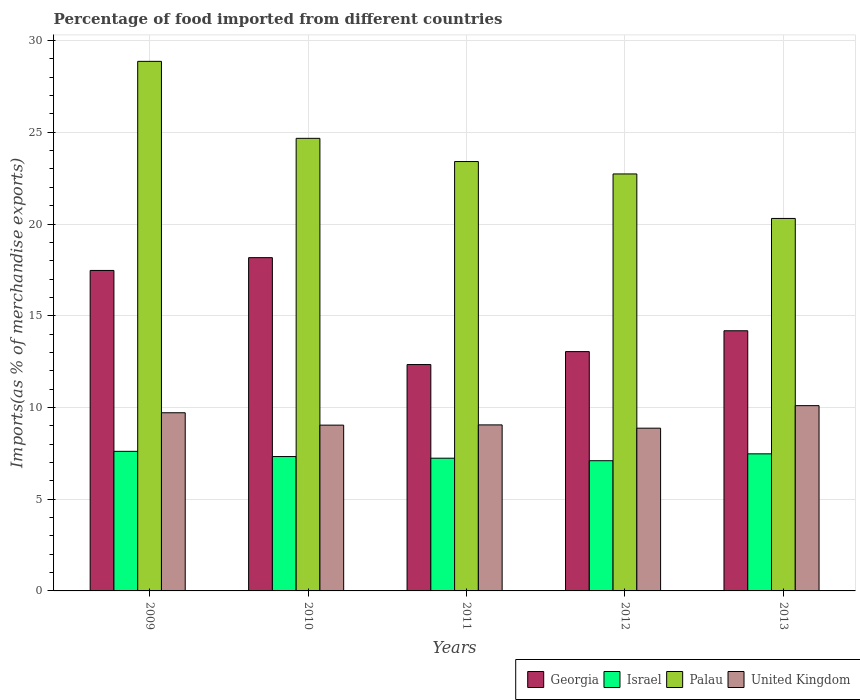How many groups of bars are there?
Make the answer very short. 5. Are the number of bars per tick equal to the number of legend labels?
Provide a succinct answer. Yes. Are the number of bars on each tick of the X-axis equal?
Your response must be concise. Yes. How many bars are there on the 4th tick from the left?
Offer a very short reply. 4. How many bars are there on the 4th tick from the right?
Offer a terse response. 4. In how many cases, is the number of bars for a given year not equal to the number of legend labels?
Your answer should be compact. 0. What is the percentage of imports to different countries in Israel in 2009?
Provide a short and direct response. 7.61. Across all years, what is the maximum percentage of imports to different countries in Israel?
Make the answer very short. 7.61. Across all years, what is the minimum percentage of imports to different countries in Israel?
Your answer should be compact. 7.1. What is the total percentage of imports to different countries in Georgia in the graph?
Your response must be concise. 75.2. What is the difference between the percentage of imports to different countries in Palau in 2010 and that in 2011?
Your answer should be compact. 1.27. What is the difference between the percentage of imports to different countries in Israel in 2009 and the percentage of imports to different countries in United Kingdom in 2013?
Offer a terse response. -2.49. What is the average percentage of imports to different countries in Israel per year?
Make the answer very short. 7.35. In the year 2009, what is the difference between the percentage of imports to different countries in Palau and percentage of imports to different countries in Georgia?
Give a very brief answer. 11.4. In how many years, is the percentage of imports to different countries in Israel greater than 21 %?
Ensure brevity in your answer.  0. What is the ratio of the percentage of imports to different countries in Georgia in 2010 to that in 2012?
Offer a very short reply. 1.39. Is the difference between the percentage of imports to different countries in Palau in 2010 and 2012 greater than the difference between the percentage of imports to different countries in Georgia in 2010 and 2012?
Your response must be concise. No. What is the difference between the highest and the second highest percentage of imports to different countries in Palau?
Provide a short and direct response. 4.2. What is the difference between the highest and the lowest percentage of imports to different countries in Israel?
Your response must be concise. 0.51. In how many years, is the percentage of imports to different countries in Israel greater than the average percentage of imports to different countries in Israel taken over all years?
Your answer should be very brief. 2. What does the 4th bar from the left in 2012 represents?
Offer a terse response. United Kingdom. What does the 4th bar from the right in 2011 represents?
Your answer should be very brief. Georgia. Is it the case that in every year, the sum of the percentage of imports to different countries in Palau and percentage of imports to different countries in United Kingdom is greater than the percentage of imports to different countries in Israel?
Offer a very short reply. Yes. Are all the bars in the graph horizontal?
Give a very brief answer. No. How many years are there in the graph?
Offer a terse response. 5. Are the values on the major ticks of Y-axis written in scientific E-notation?
Give a very brief answer. No. Does the graph contain grids?
Make the answer very short. Yes. What is the title of the graph?
Your answer should be very brief. Percentage of food imported from different countries. Does "Fiji" appear as one of the legend labels in the graph?
Make the answer very short. No. What is the label or title of the X-axis?
Offer a very short reply. Years. What is the label or title of the Y-axis?
Offer a terse response. Imports(as % of merchandise exports). What is the Imports(as % of merchandise exports) of Georgia in 2009?
Your answer should be very brief. 17.47. What is the Imports(as % of merchandise exports) of Israel in 2009?
Offer a terse response. 7.61. What is the Imports(as % of merchandise exports) in Palau in 2009?
Make the answer very short. 28.87. What is the Imports(as % of merchandise exports) in United Kingdom in 2009?
Give a very brief answer. 9.71. What is the Imports(as % of merchandise exports) in Georgia in 2010?
Ensure brevity in your answer.  18.17. What is the Imports(as % of merchandise exports) in Israel in 2010?
Keep it short and to the point. 7.32. What is the Imports(as % of merchandise exports) of Palau in 2010?
Give a very brief answer. 24.67. What is the Imports(as % of merchandise exports) of United Kingdom in 2010?
Ensure brevity in your answer.  9.04. What is the Imports(as % of merchandise exports) in Georgia in 2011?
Your answer should be very brief. 12.34. What is the Imports(as % of merchandise exports) of Israel in 2011?
Ensure brevity in your answer.  7.24. What is the Imports(as % of merchandise exports) of Palau in 2011?
Make the answer very short. 23.4. What is the Imports(as % of merchandise exports) in United Kingdom in 2011?
Your response must be concise. 9.05. What is the Imports(as % of merchandise exports) in Georgia in 2012?
Provide a succinct answer. 13.04. What is the Imports(as % of merchandise exports) of Israel in 2012?
Your answer should be very brief. 7.1. What is the Imports(as % of merchandise exports) of Palau in 2012?
Provide a succinct answer. 22.73. What is the Imports(as % of merchandise exports) in United Kingdom in 2012?
Provide a succinct answer. 8.87. What is the Imports(as % of merchandise exports) of Georgia in 2013?
Your response must be concise. 14.18. What is the Imports(as % of merchandise exports) in Israel in 2013?
Provide a succinct answer. 7.47. What is the Imports(as % of merchandise exports) of Palau in 2013?
Give a very brief answer. 20.3. What is the Imports(as % of merchandise exports) in United Kingdom in 2013?
Provide a short and direct response. 10.1. Across all years, what is the maximum Imports(as % of merchandise exports) in Georgia?
Your answer should be very brief. 18.17. Across all years, what is the maximum Imports(as % of merchandise exports) of Israel?
Your response must be concise. 7.61. Across all years, what is the maximum Imports(as % of merchandise exports) in Palau?
Provide a succinct answer. 28.87. Across all years, what is the maximum Imports(as % of merchandise exports) of United Kingdom?
Give a very brief answer. 10.1. Across all years, what is the minimum Imports(as % of merchandise exports) of Georgia?
Keep it short and to the point. 12.34. Across all years, what is the minimum Imports(as % of merchandise exports) in Israel?
Provide a short and direct response. 7.1. Across all years, what is the minimum Imports(as % of merchandise exports) of Palau?
Your answer should be very brief. 20.3. Across all years, what is the minimum Imports(as % of merchandise exports) in United Kingdom?
Your answer should be very brief. 8.87. What is the total Imports(as % of merchandise exports) in Georgia in the graph?
Ensure brevity in your answer.  75.2. What is the total Imports(as % of merchandise exports) in Israel in the graph?
Provide a succinct answer. 36.74. What is the total Imports(as % of merchandise exports) in Palau in the graph?
Offer a very short reply. 119.97. What is the total Imports(as % of merchandise exports) in United Kingdom in the graph?
Keep it short and to the point. 46.77. What is the difference between the Imports(as % of merchandise exports) of Georgia in 2009 and that in 2010?
Your response must be concise. -0.7. What is the difference between the Imports(as % of merchandise exports) of Israel in 2009 and that in 2010?
Give a very brief answer. 0.28. What is the difference between the Imports(as % of merchandise exports) in Palau in 2009 and that in 2010?
Provide a succinct answer. 4.2. What is the difference between the Imports(as % of merchandise exports) of United Kingdom in 2009 and that in 2010?
Ensure brevity in your answer.  0.67. What is the difference between the Imports(as % of merchandise exports) of Georgia in 2009 and that in 2011?
Your answer should be compact. 5.13. What is the difference between the Imports(as % of merchandise exports) in Israel in 2009 and that in 2011?
Make the answer very short. 0.37. What is the difference between the Imports(as % of merchandise exports) of Palau in 2009 and that in 2011?
Provide a succinct answer. 5.46. What is the difference between the Imports(as % of merchandise exports) in United Kingdom in 2009 and that in 2011?
Your response must be concise. 0.66. What is the difference between the Imports(as % of merchandise exports) of Georgia in 2009 and that in 2012?
Your answer should be very brief. 4.42. What is the difference between the Imports(as % of merchandise exports) in Israel in 2009 and that in 2012?
Your answer should be compact. 0.51. What is the difference between the Imports(as % of merchandise exports) of Palau in 2009 and that in 2012?
Ensure brevity in your answer.  6.14. What is the difference between the Imports(as % of merchandise exports) in United Kingdom in 2009 and that in 2012?
Offer a terse response. 0.84. What is the difference between the Imports(as % of merchandise exports) of Georgia in 2009 and that in 2013?
Offer a terse response. 3.29. What is the difference between the Imports(as % of merchandise exports) of Israel in 2009 and that in 2013?
Provide a succinct answer. 0.14. What is the difference between the Imports(as % of merchandise exports) in Palau in 2009 and that in 2013?
Keep it short and to the point. 8.56. What is the difference between the Imports(as % of merchandise exports) in United Kingdom in 2009 and that in 2013?
Offer a terse response. -0.39. What is the difference between the Imports(as % of merchandise exports) in Georgia in 2010 and that in 2011?
Provide a short and direct response. 5.83. What is the difference between the Imports(as % of merchandise exports) of Israel in 2010 and that in 2011?
Offer a terse response. 0.09. What is the difference between the Imports(as % of merchandise exports) of Palau in 2010 and that in 2011?
Give a very brief answer. 1.27. What is the difference between the Imports(as % of merchandise exports) of United Kingdom in 2010 and that in 2011?
Give a very brief answer. -0.01. What is the difference between the Imports(as % of merchandise exports) of Georgia in 2010 and that in 2012?
Make the answer very short. 5.12. What is the difference between the Imports(as % of merchandise exports) of Israel in 2010 and that in 2012?
Your answer should be compact. 0.23. What is the difference between the Imports(as % of merchandise exports) in Palau in 2010 and that in 2012?
Make the answer very short. 1.94. What is the difference between the Imports(as % of merchandise exports) in United Kingdom in 2010 and that in 2012?
Provide a succinct answer. 0.17. What is the difference between the Imports(as % of merchandise exports) of Georgia in 2010 and that in 2013?
Offer a very short reply. 3.99. What is the difference between the Imports(as % of merchandise exports) in Israel in 2010 and that in 2013?
Keep it short and to the point. -0.15. What is the difference between the Imports(as % of merchandise exports) of Palau in 2010 and that in 2013?
Offer a very short reply. 4.37. What is the difference between the Imports(as % of merchandise exports) of United Kingdom in 2010 and that in 2013?
Your answer should be very brief. -1.06. What is the difference between the Imports(as % of merchandise exports) in Georgia in 2011 and that in 2012?
Your answer should be very brief. -0.71. What is the difference between the Imports(as % of merchandise exports) of Israel in 2011 and that in 2012?
Provide a short and direct response. 0.14. What is the difference between the Imports(as % of merchandise exports) of Palau in 2011 and that in 2012?
Your answer should be compact. 0.68. What is the difference between the Imports(as % of merchandise exports) of United Kingdom in 2011 and that in 2012?
Provide a short and direct response. 0.18. What is the difference between the Imports(as % of merchandise exports) of Georgia in 2011 and that in 2013?
Your answer should be very brief. -1.84. What is the difference between the Imports(as % of merchandise exports) in Israel in 2011 and that in 2013?
Your response must be concise. -0.24. What is the difference between the Imports(as % of merchandise exports) of Palau in 2011 and that in 2013?
Offer a very short reply. 3.1. What is the difference between the Imports(as % of merchandise exports) in United Kingdom in 2011 and that in 2013?
Your answer should be compact. -1.05. What is the difference between the Imports(as % of merchandise exports) in Georgia in 2012 and that in 2013?
Offer a very short reply. -1.14. What is the difference between the Imports(as % of merchandise exports) in Israel in 2012 and that in 2013?
Provide a short and direct response. -0.38. What is the difference between the Imports(as % of merchandise exports) in Palau in 2012 and that in 2013?
Your answer should be compact. 2.43. What is the difference between the Imports(as % of merchandise exports) of United Kingdom in 2012 and that in 2013?
Give a very brief answer. -1.23. What is the difference between the Imports(as % of merchandise exports) in Georgia in 2009 and the Imports(as % of merchandise exports) in Israel in 2010?
Your answer should be very brief. 10.14. What is the difference between the Imports(as % of merchandise exports) of Georgia in 2009 and the Imports(as % of merchandise exports) of Palau in 2010?
Ensure brevity in your answer.  -7.2. What is the difference between the Imports(as % of merchandise exports) of Georgia in 2009 and the Imports(as % of merchandise exports) of United Kingdom in 2010?
Provide a succinct answer. 8.43. What is the difference between the Imports(as % of merchandise exports) of Israel in 2009 and the Imports(as % of merchandise exports) of Palau in 2010?
Your response must be concise. -17.06. What is the difference between the Imports(as % of merchandise exports) in Israel in 2009 and the Imports(as % of merchandise exports) in United Kingdom in 2010?
Give a very brief answer. -1.43. What is the difference between the Imports(as % of merchandise exports) of Palau in 2009 and the Imports(as % of merchandise exports) of United Kingdom in 2010?
Make the answer very short. 19.83. What is the difference between the Imports(as % of merchandise exports) of Georgia in 2009 and the Imports(as % of merchandise exports) of Israel in 2011?
Provide a short and direct response. 10.23. What is the difference between the Imports(as % of merchandise exports) in Georgia in 2009 and the Imports(as % of merchandise exports) in Palau in 2011?
Keep it short and to the point. -5.94. What is the difference between the Imports(as % of merchandise exports) in Georgia in 2009 and the Imports(as % of merchandise exports) in United Kingdom in 2011?
Your answer should be compact. 8.42. What is the difference between the Imports(as % of merchandise exports) of Israel in 2009 and the Imports(as % of merchandise exports) of Palau in 2011?
Ensure brevity in your answer.  -15.8. What is the difference between the Imports(as % of merchandise exports) in Israel in 2009 and the Imports(as % of merchandise exports) in United Kingdom in 2011?
Ensure brevity in your answer.  -1.44. What is the difference between the Imports(as % of merchandise exports) in Palau in 2009 and the Imports(as % of merchandise exports) in United Kingdom in 2011?
Ensure brevity in your answer.  19.82. What is the difference between the Imports(as % of merchandise exports) of Georgia in 2009 and the Imports(as % of merchandise exports) of Israel in 2012?
Offer a terse response. 10.37. What is the difference between the Imports(as % of merchandise exports) in Georgia in 2009 and the Imports(as % of merchandise exports) in Palau in 2012?
Ensure brevity in your answer.  -5.26. What is the difference between the Imports(as % of merchandise exports) in Georgia in 2009 and the Imports(as % of merchandise exports) in United Kingdom in 2012?
Offer a very short reply. 8.6. What is the difference between the Imports(as % of merchandise exports) in Israel in 2009 and the Imports(as % of merchandise exports) in Palau in 2012?
Offer a very short reply. -15.12. What is the difference between the Imports(as % of merchandise exports) in Israel in 2009 and the Imports(as % of merchandise exports) in United Kingdom in 2012?
Provide a succinct answer. -1.26. What is the difference between the Imports(as % of merchandise exports) of Palau in 2009 and the Imports(as % of merchandise exports) of United Kingdom in 2012?
Provide a succinct answer. 20. What is the difference between the Imports(as % of merchandise exports) of Georgia in 2009 and the Imports(as % of merchandise exports) of Israel in 2013?
Provide a short and direct response. 10. What is the difference between the Imports(as % of merchandise exports) of Georgia in 2009 and the Imports(as % of merchandise exports) of Palau in 2013?
Provide a short and direct response. -2.83. What is the difference between the Imports(as % of merchandise exports) of Georgia in 2009 and the Imports(as % of merchandise exports) of United Kingdom in 2013?
Make the answer very short. 7.37. What is the difference between the Imports(as % of merchandise exports) in Israel in 2009 and the Imports(as % of merchandise exports) in Palau in 2013?
Keep it short and to the point. -12.69. What is the difference between the Imports(as % of merchandise exports) in Israel in 2009 and the Imports(as % of merchandise exports) in United Kingdom in 2013?
Your answer should be very brief. -2.49. What is the difference between the Imports(as % of merchandise exports) in Palau in 2009 and the Imports(as % of merchandise exports) in United Kingdom in 2013?
Provide a short and direct response. 18.77. What is the difference between the Imports(as % of merchandise exports) in Georgia in 2010 and the Imports(as % of merchandise exports) in Israel in 2011?
Offer a terse response. 10.93. What is the difference between the Imports(as % of merchandise exports) in Georgia in 2010 and the Imports(as % of merchandise exports) in Palau in 2011?
Give a very brief answer. -5.24. What is the difference between the Imports(as % of merchandise exports) of Georgia in 2010 and the Imports(as % of merchandise exports) of United Kingdom in 2011?
Offer a very short reply. 9.12. What is the difference between the Imports(as % of merchandise exports) of Israel in 2010 and the Imports(as % of merchandise exports) of Palau in 2011?
Your answer should be compact. -16.08. What is the difference between the Imports(as % of merchandise exports) in Israel in 2010 and the Imports(as % of merchandise exports) in United Kingdom in 2011?
Provide a succinct answer. -1.73. What is the difference between the Imports(as % of merchandise exports) of Palau in 2010 and the Imports(as % of merchandise exports) of United Kingdom in 2011?
Your answer should be compact. 15.62. What is the difference between the Imports(as % of merchandise exports) in Georgia in 2010 and the Imports(as % of merchandise exports) in Israel in 2012?
Give a very brief answer. 11.07. What is the difference between the Imports(as % of merchandise exports) of Georgia in 2010 and the Imports(as % of merchandise exports) of Palau in 2012?
Your answer should be very brief. -4.56. What is the difference between the Imports(as % of merchandise exports) of Georgia in 2010 and the Imports(as % of merchandise exports) of United Kingdom in 2012?
Provide a succinct answer. 9.3. What is the difference between the Imports(as % of merchandise exports) in Israel in 2010 and the Imports(as % of merchandise exports) in Palau in 2012?
Keep it short and to the point. -15.4. What is the difference between the Imports(as % of merchandise exports) of Israel in 2010 and the Imports(as % of merchandise exports) of United Kingdom in 2012?
Give a very brief answer. -1.55. What is the difference between the Imports(as % of merchandise exports) in Palau in 2010 and the Imports(as % of merchandise exports) in United Kingdom in 2012?
Offer a very short reply. 15.8. What is the difference between the Imports(as % of merchandise exports) of Georgia in 2010 and the Imports(as % of merchandise exports) of Israel in 2013?
Offer a terse response. 10.69. What is the difference between the Imports(as % of merchandise exports) in Georgia in 2010 and the Imports(as % of merchandise exports) in Palau in 2013?
Provide a succinct answer. -2.14. What is the difference between the Imports(as % of merchandise exports) of Georgia in 2010 and the Imports(as % of merchandise exports) of United Kingdom in 2013?
Give a very brief answer. 8.07. What is the difference between the Imports(as % of merchandise exports) in Israel in 2010 and the Imports(as % of merchandise exports) in Palau in 2013?
Offer a terse response. -12.98. What is the difference between the Imports(as % of merchandise exports) in Israel in 2010 and the Imports(as % of merchandise exports) in United Kingdom in 2013?
Your response must be concise. -2.77. What is the difference between the Imports(as % of merchandise exports) of Palau in 2010 and the Imports(as % of merchandise exports) of United Kingdom in 2013?
Your answer should be compact. 14.57. What is the difference between the Imports(as % of merchandise exports) of Georgia in 2011 and the Imports(as % of merchandise exports) of Israel in 2012?
Give a very brief answer. 5.24. What is the difference between the Imports(as % of merchandise exports) of Georgia in 2011 and the Imports(as % of merchandise exports) of Palau in 2012?
Offer a terse response. -10.39. What is the difference between the Imports(as % of merchandise exports) of Georgia in 2011 and the Imports(as % of merchandise exports) of United Kingdom in 2012?
Provide a short and direct response. 3.47. What is the difference between the Imports(as % of merchandise exports) in Israel in 2011 and the Imports(as % of merchandise exports) in Palau in 2012?
Your response must be concise. -15.49. What is the difference between the Imports(as % of merchandise exports) in Israel in 2011 and the Imports(as % of merchandise exports) in United Kingdom in 2012?
Offer a terse response. -1.64. What is the difference between the Imports(as % of merchandise exports) of Palau in 2011 and the Imports(as % of merchandise exports) of United Kingdom in 2012?
Ensure brevity in your answer.  14.53. What is the difference between the Imports(as % of merchandise exports) in Georgia in 2011 and the Imports(as % of merchandise exports) in Israel in 2013?
Make the answer very short. 4.87. What is the difference between the Imports(as % of merchandise exports) of Georgia in 2011 and the Imports(as % of merchandise exports) of Palau in 2013?
Your answer should be very brief. -7.96. What is the difference between the Imports(as % of merchandise exports) in Georgia in 2011 and the Imports(as % of merchandise exports) in United Kingdom in 2013?
Your response must be concise. 2.24. What is the difference between the Imports(as % of merchandise exports) of Israel in 2011 and the Imports(as % of merchandise exports) of Palau in 2013?
Offer a terse response. -13.07. What is the difference between the Imports(as % of merchandise exports) in Israel in 2011 and the Imports(as % of merchandise exports) in United Kingdom in 2013?
Keep it short and to the point. -2.86. What is the difference between the Imports(as % of merchandise exports) of Palau in 2011 and the Imports(as % of merchandise exports) of United Kingdom in 2013?
Your answer should be compact. 13.31. What is the difference between the Imports(as % of merchandise exports) of Georgia in 2012 and the Imports(as % of merchandise exports) of Israel in 2013?
Ensure brevity in your answer.  5.57. What is the difference between the Imports(as % of merchandise exports) of Georgia in 2012 and the Imports(as % of merchandise exports) of Palau in 2013?
Your answer should be compact. -7.26. What is the difference between the Imports(as % of merchandise exports) of Georgia in 2012 and the Imports(as % of merchandise exports) of United Kingdom in 2013?
Offer a very short reply. 2.95. What is the difference between the Imports(as % of merchandise exports) of Israel in 2012 and the Imports(as % of merchandise exports) of Palau in 2013?
Ensure brevity in your answer.  -13.21. What is the difference between the Imports(as % of merchandise exports) in Israel in 2012 and the Imports(as % of merchandise exports) in United Kingdom in 2013?
Your answer should be very brief. -3. What is the difference between the Imports(as % of merchandise exports) in Palau in 2012 and the Imports(as % of merchandise exports) in United Kingdom in 2013?
Ensure brevity in your answer.  12.63. What is the average Imports(as % of merchandise exports) in Georgia per year?
Offer a terse response. 15.04. What is the average Imports(as % of merchandise exports) in Israel per year?
Ensure brevity in your answer.  7.35. What is the average Imports(as % of merchandise exports) in Palau per year?
Make the answer very short. 23.99. What is the average Imports(as % of merchandise exports) in United Kingdom per year?
Make the answer very short. 9.35. In the year 2009, what is the difference between the Imports(as % of merchandise exports) of Georgia and Imports(as % of merchandise exports) of Israel?
Make the answer very short. 9.86. In the year 2009, what is the difference between the Imports(as % of merchandise exports) of Georgia and Imports(as % of merchandise exports) of Palau?
Your answer should be compact. -11.4. In the year 2009, what is the difference between the Imports(as % of merchandise exports) in Georgia and Imports(as % of merchandise exports) in United Kingdom?
Offer a very short reply. 7.76. In the year 2009, what is the difference between the Imports(as % of merchandise exports) in Israel and Imports(as % of merchandise exports) in Palau?
Your answer should be compact. -21.26. In the year 2009, what is the difference between the Imports(as % of merchandise exports) of Israel and Imports(as % of merchandise exports) of United Kingdom?
Give a very brief answer. -2.1. In the year 2009, what is the difference between the Imports(as % of merchandise exports) in Palau and Imports(as % of merchandise exports) in United Kingdom?
Your response must be concise. 19.15. In the year 2010, what is the difference between the Imports(as % of merchandise exports) in Georgia and Imports(as % of merchandise exports) in Israel?
Your answer should be very brief. 10.84. In the year 2010, what is the difference between the Imports(as % of merchandise exports) in Georgia and Imports(as % of merchandise exports) in Palau?
Your answer should be very brief. -6.5. In the year 2010, what is the difference between the Imports(as % of merchandise exports) of Georgia and Imports(as % of merchandise exports) of United Kingdom?
Your answer should be very brief. 9.13. In the year 2010, what is the difference between the Imports(as % of merchandise exports) of Israel and Imports(as % of merchandise exports) of Palau?
Provide a short and direct response. -17.35. In the year 2010, what is the difference between the Imports(as % of merchandise exports) of Israel and Imports(as % of merchandise exports) of United Kingdom?
Ensure brevity in your answer.  -1.71. In the year 2010, what is the difference between the Imports(as % of merchandise exports) of Palau and Imports(as % of merchandise exports) of United Kingdom?
Give a very brief answer. 15.63. In the year 2011, what is the difference between the Imports(as % of merchandise exports) in Georgia and Imports(as % of merchandise exports) in Israel?
Provide a succinct answer. 5.1. In the year 2011, what is the difference between the Imports(as % of merchandise exports) in Georgia and Imports(as % of merchandise exports) in Palau?
Your answer should be very brief. -11.07. In the year 2011, what is the difference between the Imports(as % of merchandise exports) of Georgia and Imports(as % of merchandise exports) of United Kingdom?
Make the answer very short. 3.29. In the year 2011, what is the difference between the Imports(as % of merchandise exports) in Israel and Imports(as % of merchandise exports) in Palau?
Your answer should be very brief. -16.17. In the year 2011, what is the difference between the Imports(as % of merchandise exports) of Israel and Imports(as % of merchandise exports) of United Kingdom?
Your answer should be compact. -1.81. In the year 2011, what is the difference between the Imports(as % of merchandise exports) in Palau and Imports(as % of merchandise exports) in United Kingdom?
Your answer should be very brief. 14.35. In the year 2012, what is the difference between the Imports(as % of merchandise exports) of Georgia and Imports(as % of merchandise exports) of Israel?
Your answer should be very brief. 5.95. In the year 2012, what is the difference between the Imports(as % of merchandise exports) of Georgia and Imports(as % of merchandise exports) of Palau?
Your response must be concise. -9.68. In the year 2012, what is the difference between the Imports(as % of merchandise exports) of Georgia and Imports(as % of merchandise exports) of United Kingdom?
Make the answer very short. 4.17. In the year 2012, what is the difference between the Imports(as % of merchandise exports) of Israel and Imports(as % of merchandise exports) of Palau?
Offer a terse response. -15.63. In the year 2012, what is the difference between the Imports(as % of merchandise exports) in Israel and Imports(as % of merchandise exports) in United Kingdom?
Offer a terse response. -1.77. In the year 2012, what is the difference between the Imports(as % of merchandise exports) in Palau and Imports(as % of merchandise exports) in United Kingdom?
Your response must be concise. 13.86. In the year 2013, what is the difference between the Imports(as % of merchandise exports) in Georgia and Imports(as % of merchandise exports) in Israel?
Your answer should be compact. 6.71. In the year 2013, what is the difference between the Imports(as % of merchandise exports) of Georgia and Imports(as % of merchandise exports) of Palau?
Ensure brevity in your answer.  -6.12. In the year 2013, what is the difference between the Imports(as % of merchandise exports) in Georgia and Imports(as % of merchandise exports) in United Kingdom?
Your answer should be very brief. 4.08. In the year 2013, what is the difference between the Imports(as % of merchandise exports) of Israel and Imports(as % of merchandise exports) of Palau?
Provide a short and direct response. -12.83. In the year 2013, what is the difference between the Imports(as % of merchandise exports) in Israel and Imports(as % of merchandise exports) in United Kingdom?
Your answer should be very brief. -2.63. In the year 2013, what is the difference between the Imports(as % of merchandise exports) in Palau and Imports(as % of merchandise exports) in United Kingdom?
Your answer should be very brief. 10.2. What is the ratio of the Imports(as % of merchandise exports) in Georgia in 2009 to that in 2010?
Your answer should be compact. 0.96. What is the ratio of the Imports(as % of merchandise exports) of Israel in 2009 to that in 2010?
Provide a short and direct response. 1.04. What is the ratio of the Imports(as % of merchandise exports) in Palau in 2009 to that in 2010?
Provide a short and direct response. 1.17. What is the ratio of the Imports(as % of merchandise exports) in United Kingdom in 2009 to that in 2010?
Ensure brevity in your answer.  1.07. What is the ratio of the Imports(as % of merchandise exports) of Georgia in 2009 to that in 2011?
Your answer should be compact. 1.42. What is the ratio of the Imports(as % of merchandise exports) in Israel in 2009 to that in 2011?
Your response must be concise. 1.05. What is the ratio of the Imports(as % of merchandise exports) in Palau in 2009 to that in 2011?
Your answer should be very brief. 1.23. What is the ratio of the Imports(as % of merchandise exports) of United Kingdom in 2009 to that in 2011?
Offer a terse response. 1.07. What is the ratio of the Imports(as % of merchandise exports) in Georgia in 2009 to that in 2012?
Your answer should be very brief. 1.34. What is the ratio of the Imports(as % of merchandise exports) in Israel in 2009 to that in 2012?
Provide a succinct answer. 1.07. What is the ratio of the Imports(as % of merchandise exports) in Palau in 2009 to that in 2012?
Offer a very short reply. 1.27. What is the ratio of the Imports(as % of merchandise exports) in United Kingdom in 2009 to that in 2012?
Make the answer very short. 1.09. What is the ratio of the Imports(as % of merchandise exports) of Georgia in 2009 to that in 2013?
Make the answer very short. 1.23. What is the ratio of the Imports(as % of merchandise exports) in Israel in 2009 to that in 2013?
Your answer should be compact. 1.02. What is the ratio of the Imports(as % of merchandise exports) of Palau in 2009 to that in 2013?
Your answer should be very brief. 1.42. What is the ratio of the Imports(as % of merchandise exports) in United Kingdom in 2009 to that in 2013?
Provide a short and direct response. 0.96. What is the ratio of the Imports(as % of merchandise exports) in Georgia in 2010 to that in 2011?
Your answer should be compact. 1.47. What is the ratio of the Imports(as % of merchandise exports) of Israel in 2010 to that in 2011?
Provide a succinct answer. 1.01. What is the ratio of the Imports(as % of merchandise exports) in Palau in 2010 to that in 2011?
Your response must be concise. 1.05. What is the ratio of the Imports(as % of merchandise exports) of United Kingdom in 2010 to that in 2011?
Your response must be concise. 1. What is the ratio of the Imports(as % of merchandise exports) in Georgia in 2010 to that in 2012?
Offer a very short reply. 1.39. What is the ratio of the Imports(as % of merchandise exports) of Israel in 2010 to that in 2012?
Your response must be concise. 1.03. What is the ratio of the Imports(as % of merchandise exports) in Palau in 2010 to that in 2012?
Ensure brevity in your answer.  1.09. What is the ratio of the Imports(as % of merchandise exports) of United Kingdom in 2010 to that in 2012?
Give a very brief answer. 1.02. What is the ratio of the Imports(as % of merchandise exports) in Georgia in 2010 to that in 2013?
Keep it short and to the point. 1.28. What is the ratio of the Imports(as % of merchandise exports) of Israel in 2010 to that in 2013?
Your answer should be very brief. 0.98. What is the ratio of the Imports(as % of merchandise exports) in Palau in 2010 to that in 2013?
Your answer should be compact. 1.22. What is the ratio of the Imports(as % of merchandise exports) in United Kingdom in 2010 to that in 2013?
Your response must be concise. 0.89. What is the ratio of the Imports(as % of merchandise exports) in Georgia in 2011 to that in 2012?
Offer a very short reply. 0.95. What is the ratio of the Imports(as % of merchandise exports) of Israel in 2011 to that in 2012?
Offer a terse response. 1.02. What is the ratio of the Imports(as % of merchandise exports) in Palau in 2011 to that in 2012?
Your response must be concise. 1.03. What is the ratio of the Imports(as % of merchandise exports) in United Kingdom in 2011 to that in 2012?
Offer a terse response. 1.02. What is the ratio of the Imports(as % of merchandise exports) of Georgia in 2011 to that in 2013?
Your response must be concise. 0.87. What is the ratio of the Imports(as % of merchandise exports) of Israel in 2011 to that in 2013?
Offer a very short reply. 0.97. What is the ratio of the Imports(as % of merchandise exports) in Palau in 2011 to that in 2013?
Your answer should be compact. 1.15. What is the ratio of the Imports(as % of merchandise exports) in United Kingdom in 2011 to that in 2013?
Offer a very short reply. 0.9. What is the ratio of the Imports(as % of merchandise exports) of Georgia in 2012 to that in 2013?
Provide a short and direct response. 0.92. What is the ratio of the Imports(as % of merchandise exports) of Israel in 2012 to that in 2013?
Provide a short and direct response. 0.95. What is the ratio of the Imports(as % of merchandise exports) of Palau in 2012 to that in 2013?
Keep it short and to the point. 1.12. What is the ratio of the Imports(as % of merchandise exports) of United Kingdom in 2012 to that in 2013?
Keep it short and to the point. 0.88. What is the difference between the highest and the second highest Imports(as % of merchandise exports) of Georgia?
Offer a terse response. 0.7. What is the difference between the highest and the second highest Imports(as % of merchandise exports) of Israel?
Offer a very short reply. 0.14. What is the difference between the highest and the second highest Imports(as % of merchandise exports) in Palau?
Your answer should be very brief. 4.2. What is the difference between the highest and the second highest Imports(as % of merchandise exports) in United Kingdom?
Your answer should be very brief. 0.39. What is the difference between the highest and the lowest Imports(as % of merchandise exports) in Georgia?
Keep it short and to the point. 5.83. What is the difference between the highest and the lowest Imports(as % of merchandise exports) in Israel?
Give a very brief answer. 0.51. What is the difference between the highest and the lowest Imports(as % of merchandise exports) in Palau?
Your response must be concise. 8.56. What is the difference between the highest and the lowest Imports(as % of merchandise exports) in United Kingdom?
Provide a succinct answer. 1.23. 